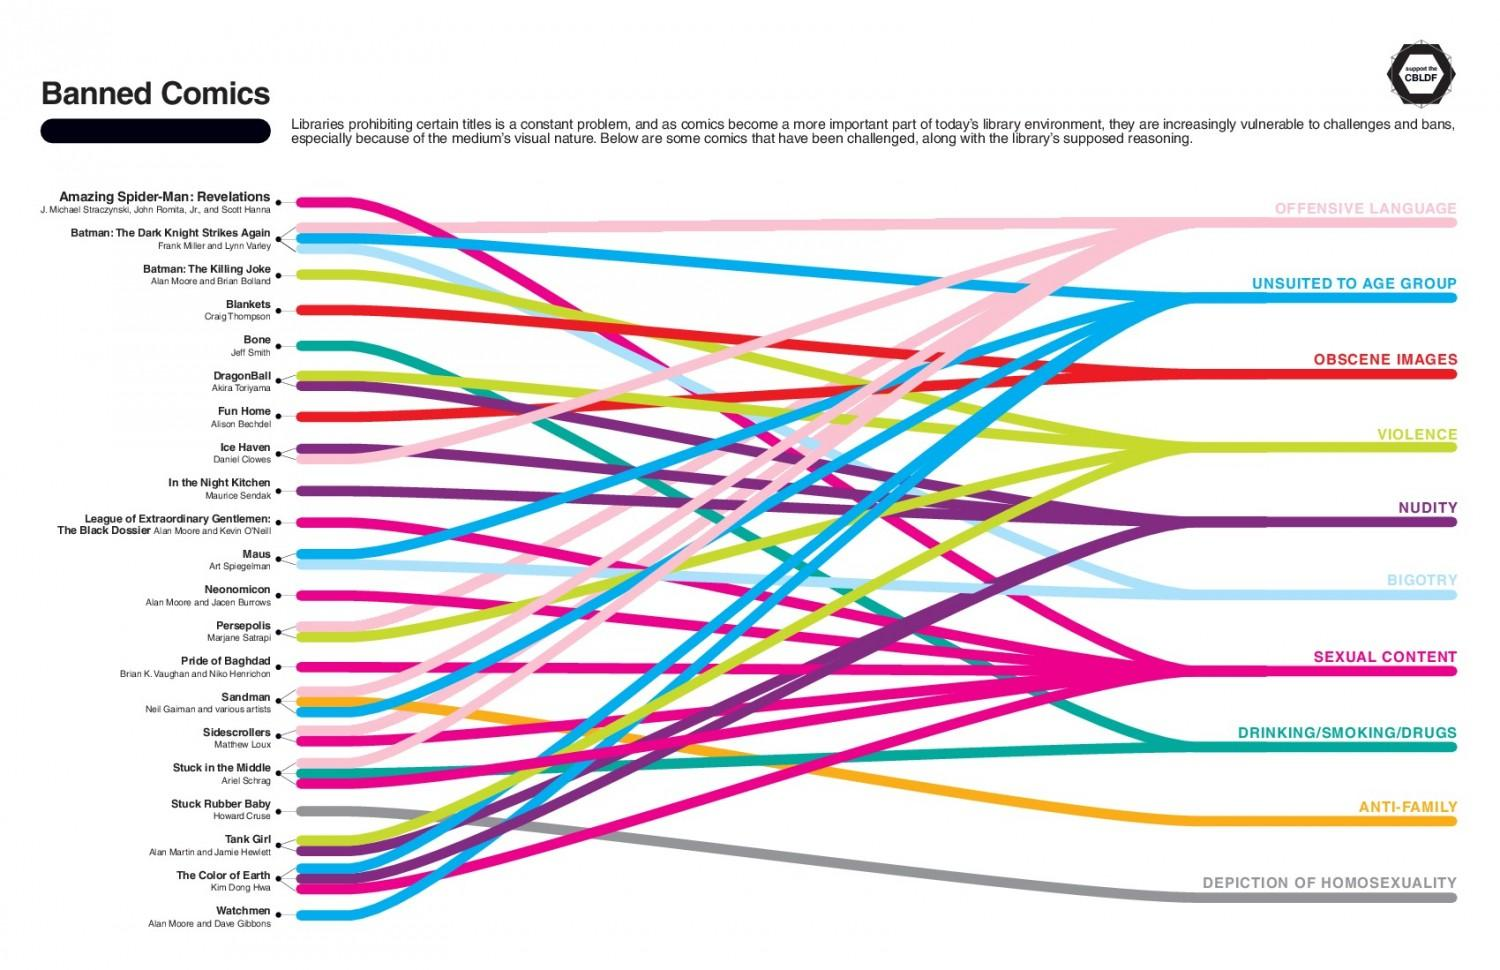Specify some key components in this picture. The comic book "Stuck Rubber Baby," written by Howard Cruse, has been banned due to its depiction of homosexuality. Sandman is a banned comic book due to its anti-family themes among the given options. The author of 'Ice Haven' is Daniel Clowes. The comic book 'Maus' has been banned due to its unsuitability for the intended age group and promoting bigotry. The comic book titled 'Bone' has been banned due to its depiction of alcohol, tobacco, and drug use. 